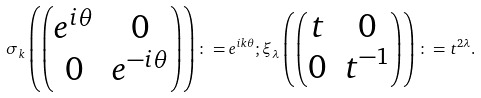<formula> <loc_0><loc_0><loc_500><loc_500>\sigma _ { k } \left ( \begin{pmatrix} e ^ { i \theta } & 0 \\ 0 & e ^ { - i \theta } \end{pmatrix} \right ) \colon = e ^ { i k \theta } ; \xi _ { \lambda } \left ( \begin{pmatrix} t & 0 \\ 0 & t ^ { - 1 } \end{pmatrix} \right ) \colon = t ^ { 2 \lambda } .</formula> 